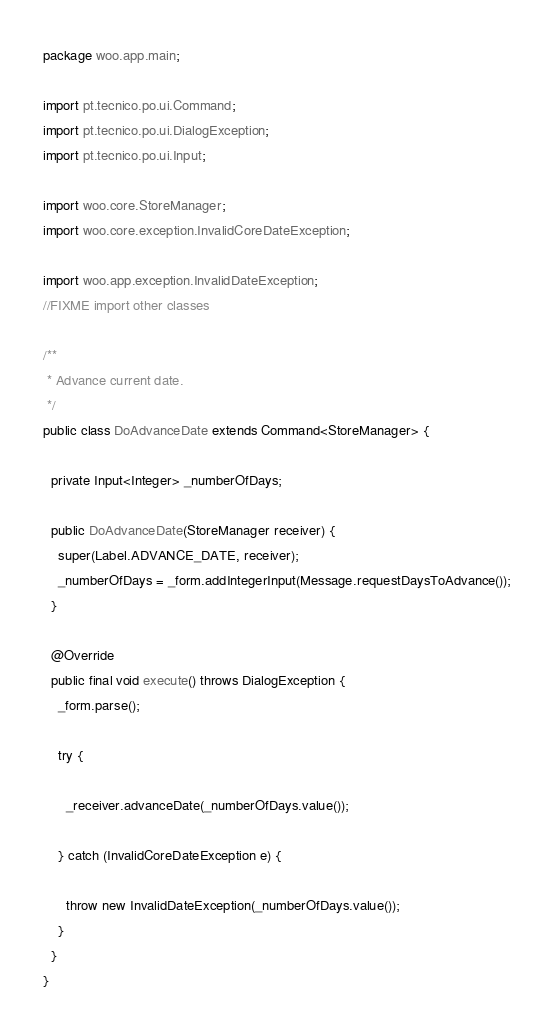<code> <loc_0><loc_0><loc_500><loc_500><_Java_>package woo.app.main;

import pt.tecnico.po.ui.Command;
import pt.tecnico.po.ui.DialogException;
import pt.tecnico.po.ui.Input;

import woo.core.StoreManager;
import woo.core.exception.InvalidCoreDateException;

import woo.app.exception.InvalidDateException;
//FIXME import other classes

/**
 * Advance current date.
 */
public class DoAdvanceDate extends Command<StoreManager> {
  
  private Input<Integer> _numberOfDays;

  public DoAdvanceDate(StoreManager receiver) {
    super(Label.ADVANCE_DATE, receiver);
    _numberOfDays = _form.addIntegerInput(Message.requestDaysToAdvance());
  }

  @Override
  public final void execute() throws DialogException {
    _form.parse();
    
    try {

      _receiver.advanceDate(_numberOfDays.value());

    } catch (InvalidCoreDateException e) {

      throw new InvalidDateException(_numberOfDays.value());
    }
  }
}
</code> 